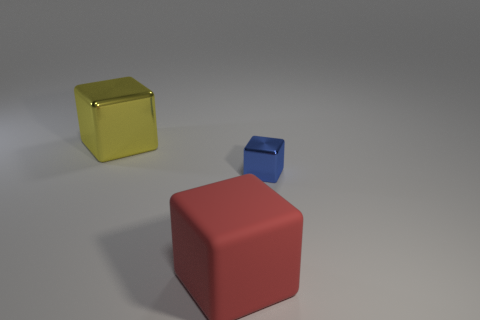Add 2 yellow metallic cubes. How many objects exist? 5 Add 2 rubber objects. How many rubber objects are left? 3 Add 2 small blocks. How many small blocks exist? 3 Subtract 1 yellow cubes. How many objects are left? 2 Subtract all matte cubes. Subtract all yellow matte balls. How many objects are left? 2 